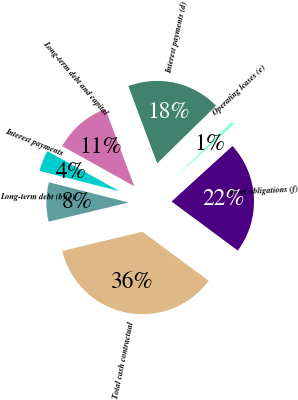<chart> <loc_0><loc_0><loc_500><loc_500><pie_chart><fcel>Long-term debt and capital<fcel>Interest payments (d)<fcel>Operating leases (e)<fcel>Other obligations (f)<fcel>Total cash contractual<fcel>Long-term debt (b)(c)<fcel>Interest payments<nl><fcel>11.24%<fcel>18.35%<fcel>0.57%<fcel>21.9%<fcel>36.12%<fcel>7.68%<fcel>4.13%<nl></chart> 